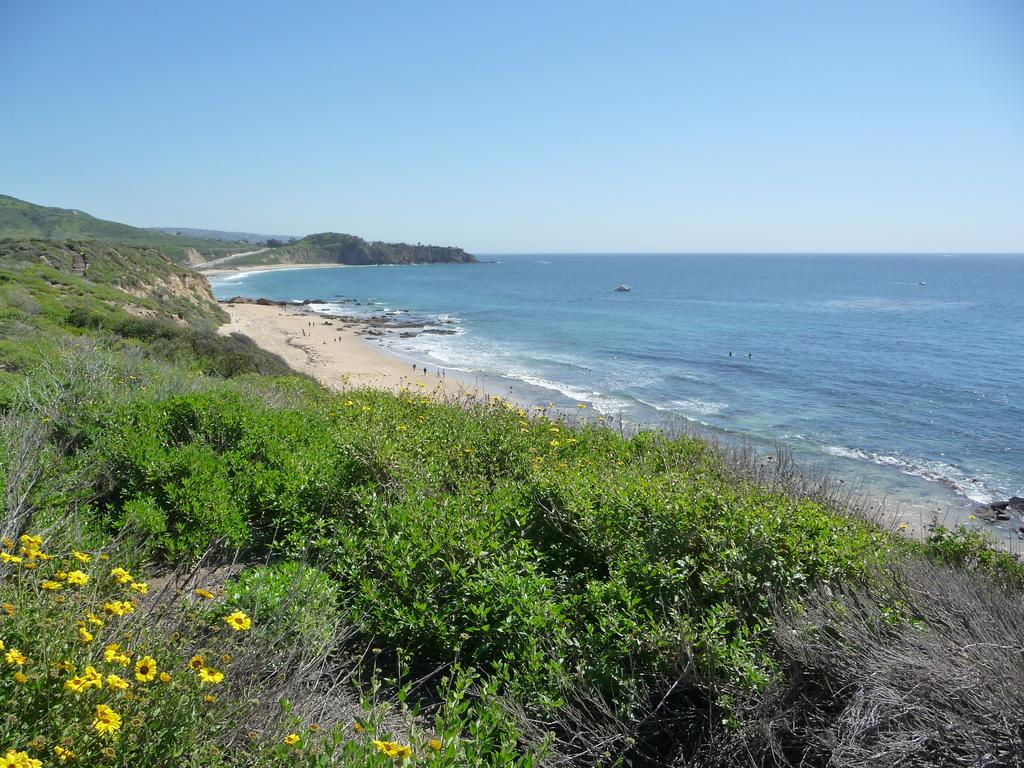What color are the flowers in the image? The flowers in the image are yellow. Where are the flowers located? The flowers are on plants. What type of vegetation can be seen in the image besides the flowers? There is dried grass visible in the image. What can be seen in the background of the image? Water is visible in the background of the image. What is the color of the sky in the image? The sky is blue in color. What type of bubble is floating in the image? There is no bubble present in the image. What ornament is hanging from the tree in the image? There is no tree or ornament present in the image. 